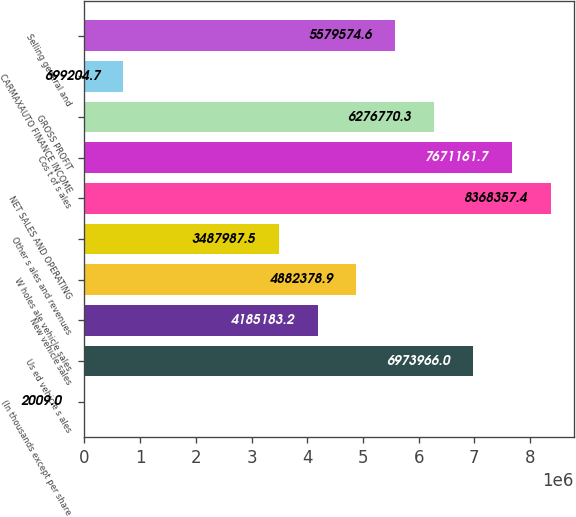Convert chart to OTSL. <chart><loc_0><loc_0><loc_500><loc_500><bar_chart><fcel>(In thousands except per share<fcel>Us ed vehicle s ales<fcel>New vehicle sales<fcel>W holes ale vehicle sales<fcel>Other s ales and revenues<fcel>NET SALES AND OPERATING<fcel>Cos t of s ales<fcel>GROSS PROFIT<fcel>CARMAXAUTO FINANCE INCOME<fcel>Selling general and<nl><fcel>2009<fcel>6.97397e+06<fcel>4.18518e+06<fcel>4.88238e+06<fcel>3.48799e+06<fcel>8.36836e+06<fcel>7.67116e+06<fcel>6.27677e+06<fcel>699205<fcel>5.57957e+06<nl></chart> 